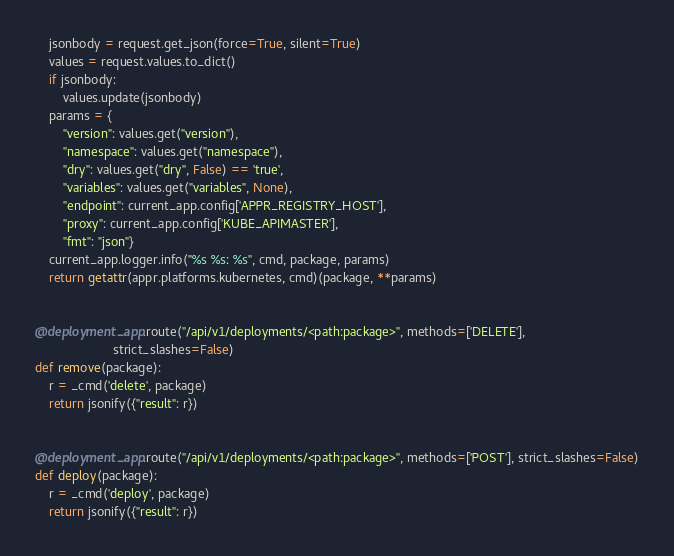<code> <loc_0><loc_0><loc_500><loc_500><_Python_>    jsonbody = request.get_json(force=True, silent=True)
    values = request.values.to_dict()
    if jsonbody:
        values.update(jsonbody)
    params = {
        "version": values.get("version"),
        "namespace": values.get("namespace"),
        "dry": values.get("dry", False) == 'true',
        "variables": values.get("variables", None),
        "endpoint": current_app.config['APPR_REGISTRY_HOST'],
        "proxy": current_app.config['KUBE_APIMASTER'],
        "fmt": "json"}
    current_app.logger.info("%s %s: %s", cmd, package, params)
    return getattr(appr.platforms.kubernetes, cmd)(package, **params)


@deployment_app.route("/api/v1/deployments/<path:package>", methods=['DELETE'],
                      strict_slashes=False)
def remove(package):
    r = _cmd('delete', package)
    return jsonify({"result": r})


@deployment_app.route("/api/v1/deployments/<path:package>", methods=['POST'], strict_slashes=False)
def deploy(package):
    r = _cmd('deploy', package)
    return jsonify({"result": r})
</code> 